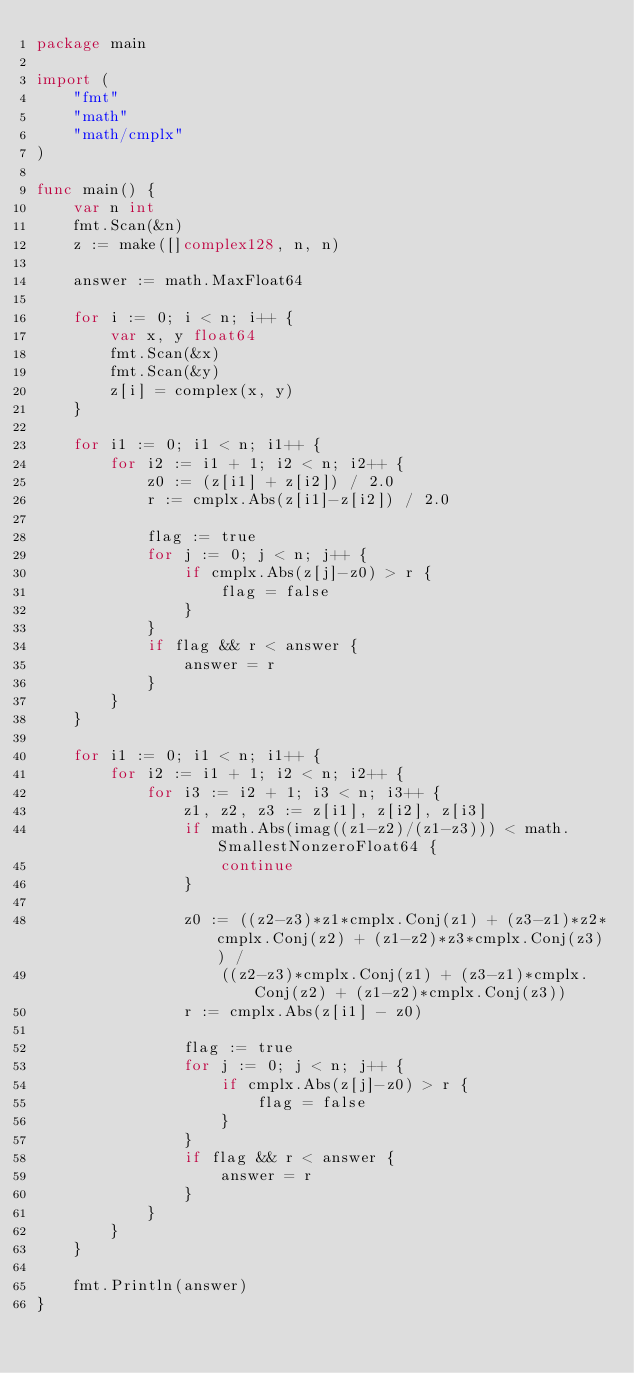<code> <loc_0><loc_0><loc_500><loc_500><_Go_>package main

import (
	"fmt"
	"math"
	"math/cmplx"
)

func main() {
	var n int
	fmt.Scan(&n)
	z := make([]complex128, n, n)

	answer := math.MaxFloat64

	for i := 0; i < n; i++ {
		var x, y float64
		fmt.Scan(&x)
		fmt.Scan(&y)
		z[i] = complex(x, y)
	}

	for i1 := 0; i1 < n; i1++ {
		for i2 := i1 + 1; i2 < n; i2++ {
			z0 := (z[i1] + z[i2]) / 2.0
			r := cmplx.Abs(z[i1]-z[i2]) / 2.0

			flag := true
			for j := 0; j < n; j++ {
				if cmplx.Abs(z[j]-z0) > r {
					flag = false
				}
			}
			if flag && r < answer {
				answer = r
			}
		}
	}

	for i1 := 0; i1 < n; i1++ {
		for i2 := i1 + 1; i2 < n; i2++ {
			for i3 := i2 + 1; i3 < n; i3++ {
				z1, z2, z3 := z[i1], z[i2], z[i3]
				if math.Abs(imag((z1-z2)/(z1-z3))) < math.SmallestNonzeroFloat64 {
					continue
				}

				z0 := ((z2-z3)*z1*cmplx.Conj(z1) + (z3-z1)*z2*cmplx.Conj(z2) + (z1-z2)*z3*cmplx.Conj(z3)) /
					((z2-z3)*cmplx.Conj(z1) + (z3-z1)*cmplx.Conj(z2) + (z1-z2)*cmplx.Conj(z3))
				r := cmplx.Abs(z[i1] - z0)

				flag := true
				for j := 0; j < n; j++ {
					if cmplx.Abs(z[j]-z0) > r {
						flag = false
					}
				}
				if flag && r < answer {
					answer = r
				}
			}
		}
	}

	fmt.Println(answer)
}
</code> 